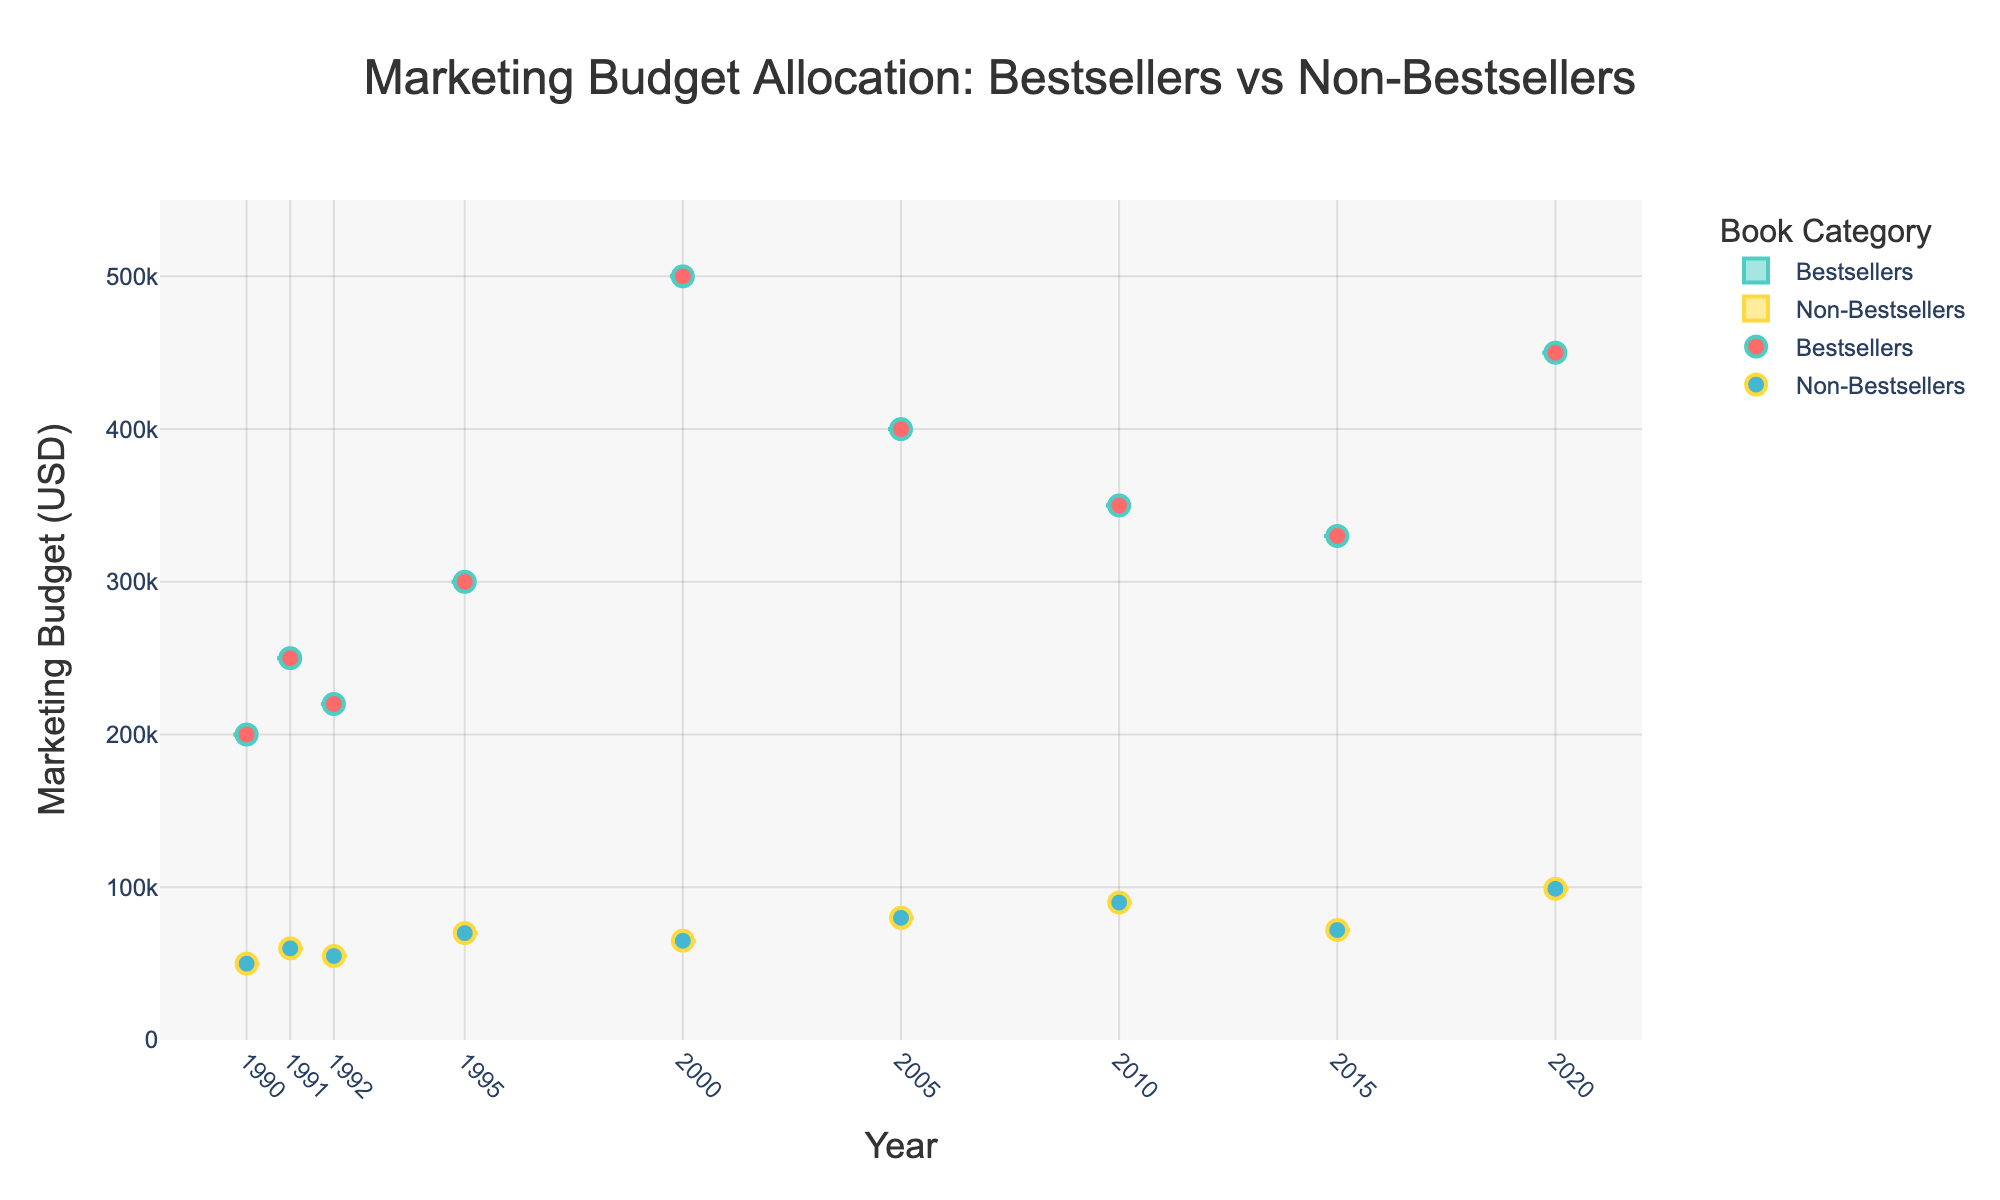What is the title of the figure? The title is typically displayed at the top of the figure and provides context about what the figure represents.
Answer: Marketing Budget Allocation: Bestsellers vs Non-Bestsellers What do the colors represent in the scatter points? The scatter points use different colors to differentiate between bestsellers and non-bestsellers: red for bestsellers and blue for non-bestsellers.
Answer: Bestsellers are red, non-bestsellers are blue What is the range of the marketing budgets displayed in the figure? The y-axis represents the marketing budget in USD, and it ranges from 0 to slightly above the highest individual budget. Specifically, the highest marketing budget is 500,000 USD, so the range is from 0 to a bit above that.
Answer: 0 to 500,000 USD How does the median marketing budget for bestsellers compare to non-bestsellers in the year 2000? The median can be visually estimated from the lines inside the box plots for the year 2000. For bestsellers, the median budget is significantly higher than that of non-bestsellers.
Answer: Higher for bestsellers What year shows the largest difference in marketing budgets between bestsellers and non-bestsellers? By comparing the box plots and scatter points, the year with the largest difference in marketing budgets can be seen where the boxes and points for both groups are most spread apart. In this case, it's the year 2000.
Answer: 2000 Which book has the highest marketing budget, and how much was it? Hovering over the scatter points, the book with the highest budget has a visible label. In this figure, it is "Harry Potter and the Goblet of Fire" with a marketing budget of 500,000 USD.
Answer: Harry Potter and the Goblet of Fire, 500,000 USD What is the trend in marketing budget allocation for bestsellers from 1990 to 2020? Observing the box plots and the scatter points, we can see if there's an upward or downward trend over the years. The trend for bestsellers shows an increase in marketing budget over this period.
Answer: Increasing Is there a year where the marketing budget for non-bestsellers is significantly high compared to other years? By looking at the box plots and scatter points, we can identify any year where non-bestsellers received an unusually high budget. This appears in the year 2020.
Answer: 2020 How do the average marketing budgets of bestsellers and non-bestsellers compare across all years? By averaging the budgets shown within the box plots (measured by the lines within the boxes), we can compare the groups. The average marketing budget for bestsellers is consistently higher than for non-bestsellers across all years.
Answer: Higher for bestsellers Which book among the non-bestsellers received the highest marketing budget and in what year? By identifying and hovering over the scatter points for non-bestsellers, we find the book with the highest budget and note the year associated with it. "The Vanishing Half" in 2020 had the highest marketing budget among non-bestsellers.
Answer: The Vanishing Half, 2020 